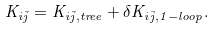Convert formula to latex. <formula><loc_0><loc_0><loc_500><loc_500>K _ { i \bar { j } } = K _ { i \bar { j } , t r e e } + \delta K _ { i \bar { j } , 1 - l o o p } .</formula> 